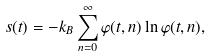Convert formula to latex. <formula><loc_0><loc_0><loc_500><loc_500>s ( t ) = - k _ { B } \sum _ { n = 0 } ^ { \infty } \varphi ( t , n ) \ln \varphi ( t , n ) ,</formula> 